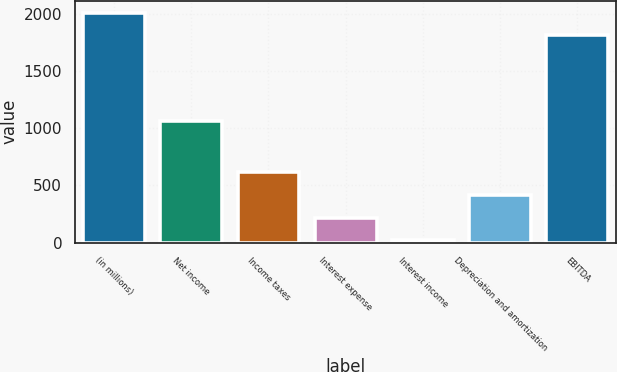Convert chart. <chart><loc_0><loc_0><loc_500><loc_500><bar_chart><fcel>(in millions)<fcel>Net income<fcel>Income taxes<fcel>Interest expense<fcel>Interest income<fcel>Depreciation and amortization<fcel>EBITDA<nl><fcel>2011.4<fcel>1062<fcel>615.2<fcel>218.4<fcel>20<fcel>416.8<fcel>1813<nl></chart> 